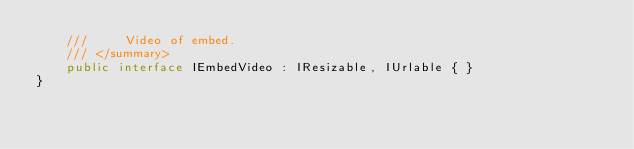Convert code to text. <code><loc_0><loc_0><loc_500><loc_500><_C#_>    ///     Video of embed.
    /// </summary>
    public interface IEmbedVideo : IResizable, IUrlable { }
}
</code> 